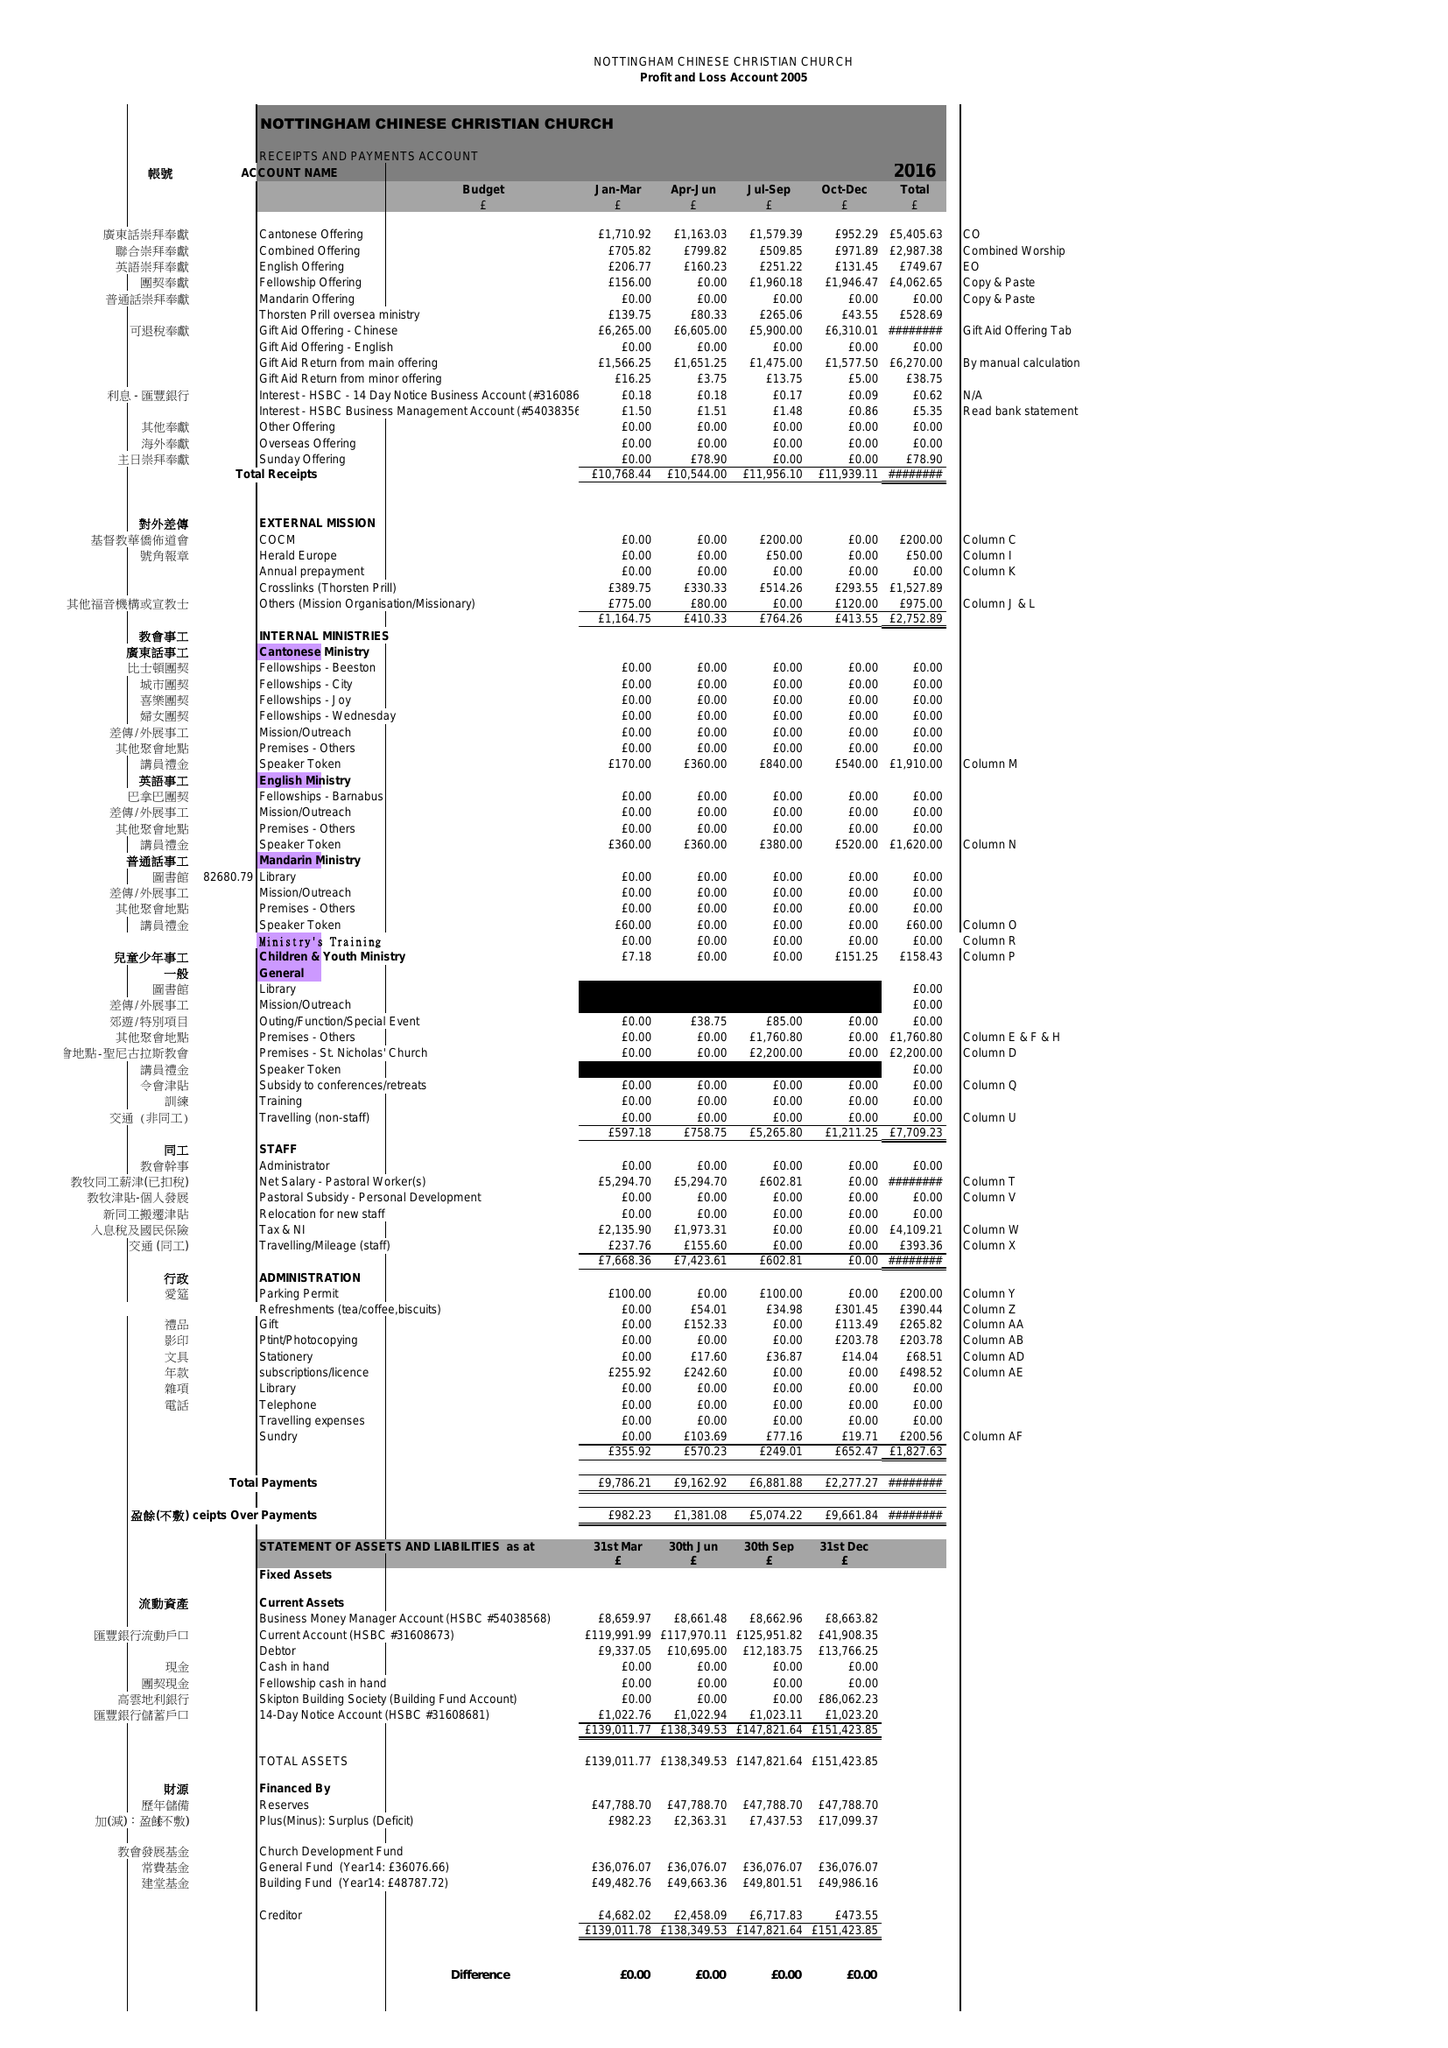What is the value for the charity_name?
Answer the question using a single word or phrase. Nottingham Chinese Christian Church 